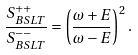<formula> <loc_0><loc_0><loc_500><loc_500>\frac { S _ { B S L T } ^ { + + } } { S _ { B S L T } ^ { - - } } = \left ( \frac { \omega + E } { \omega - E } \right ) ^ { 2 } .</formula> 